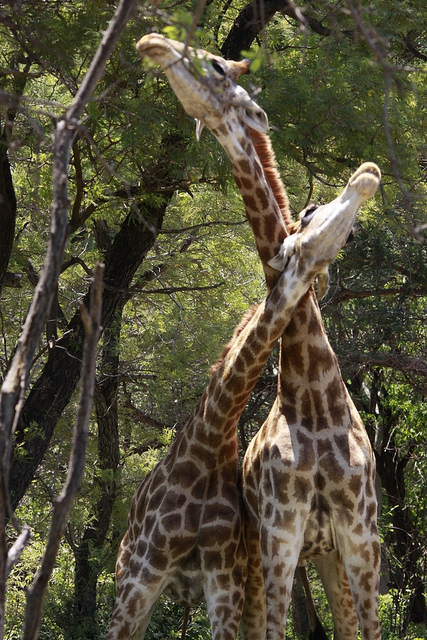How many giraffes are there? 2 